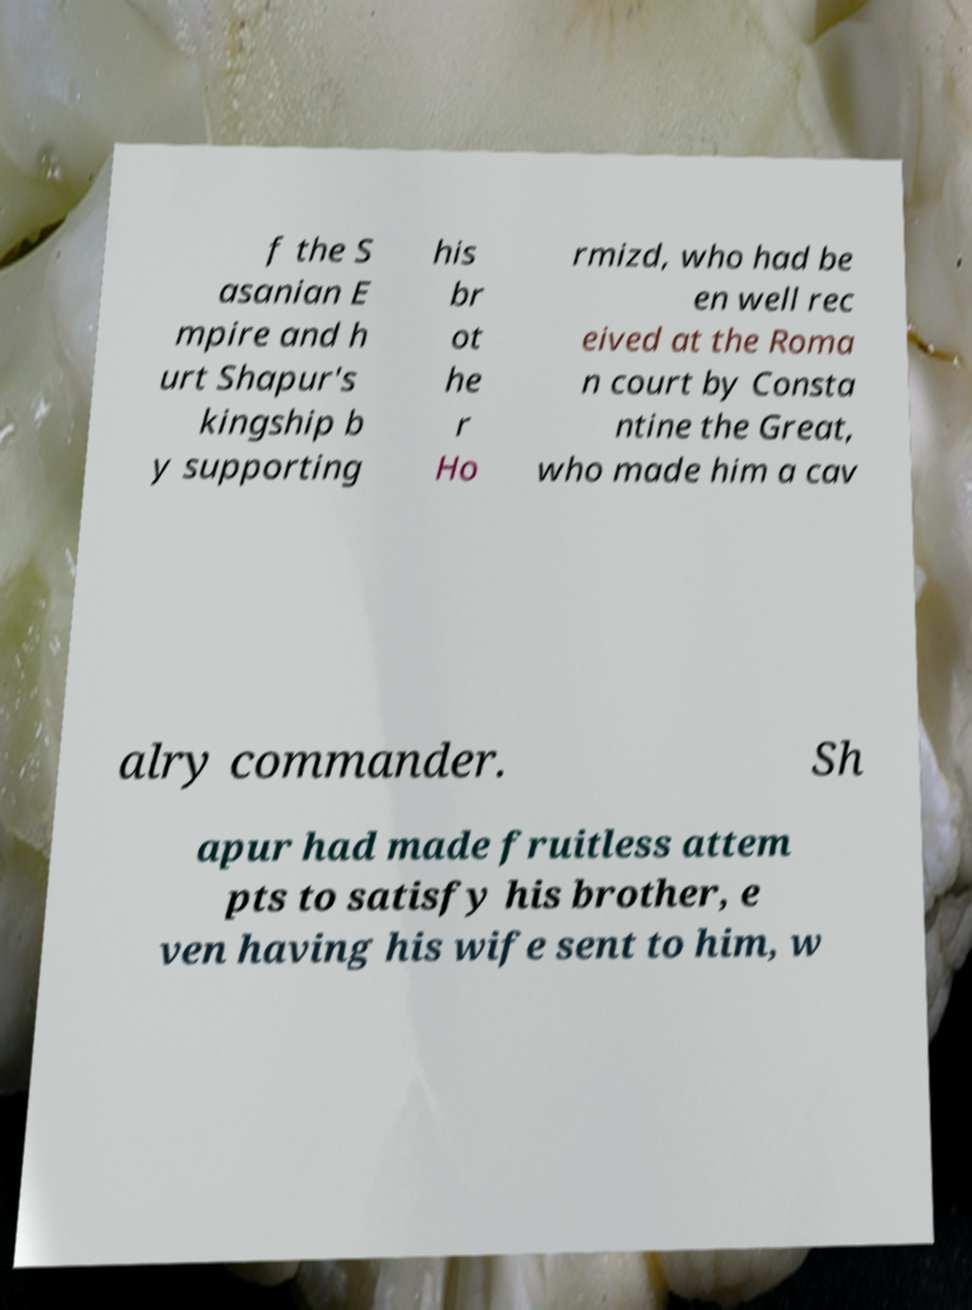Please identify and transcribe the text found in this image. f the S asanian E mpire and h urt Shapur's kingship b y supporting his br ot he r Ho rmizd, who had be en well rec eived at the Roma n court by Consta ntine the Great, who made him a cav alry commander. Sh apur had made fruitless attem pts to satisfy his brother, e ven having his wife sent to him, w 